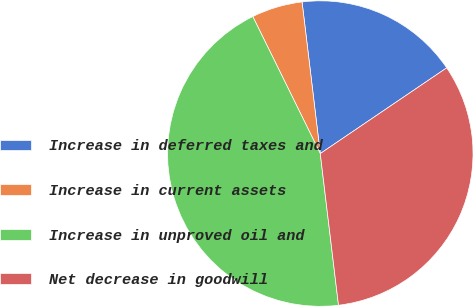Convert chart to OTSL. <chart><loc_0><loc_0><loc_500><loc_500><pie_chart><fcel>Increase in deferred taxes and<fcel>Increase in current assets<fcel>Increase in unproved oil and<fcel>Net decrease in goodwill<nl><fcel>17.42%<fcel>5.38%<fcel>44.62%<fcel>32.58%<nl></chart> 